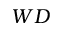Convert formula to latex. <formula><loc_0><loc_0><loc_500><loc_500>W D</formula> 